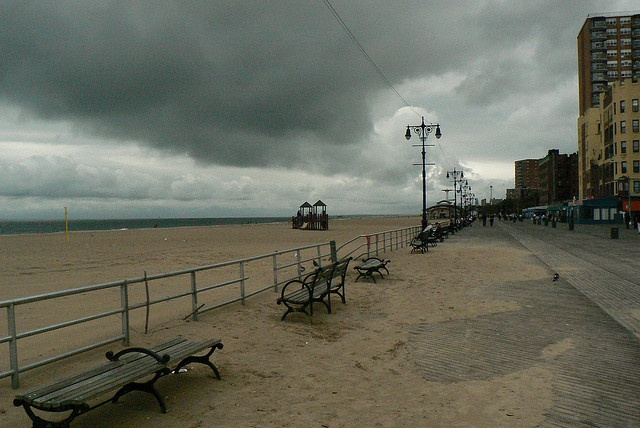Describe the objects in this image and their specific colors. I can see bench in gray, black, and darkgreen tones, bench in gray, black, and darkgreen tones, bench in gray, black, and darkgreen tones, bench in gray, black, and darkgreen tones, and people in gray, black, and maroon tones in this image. 